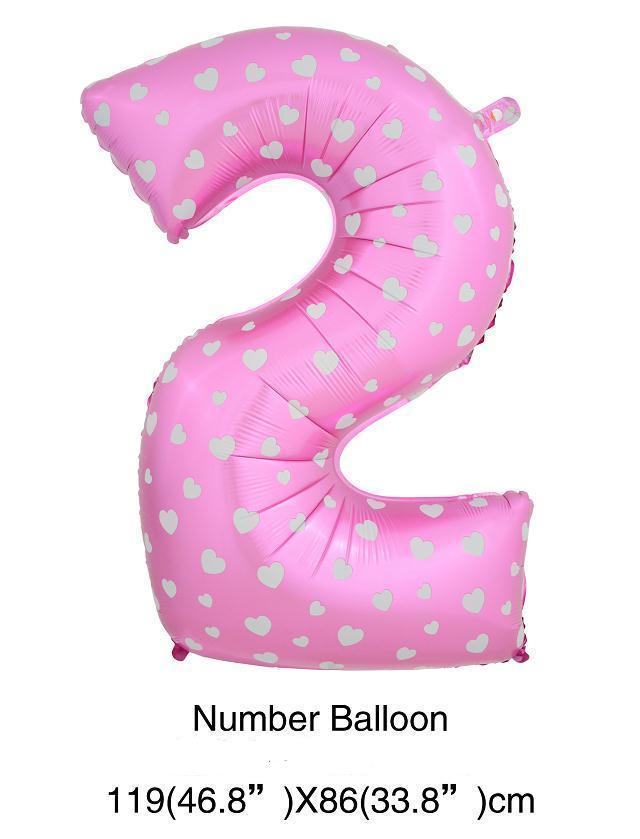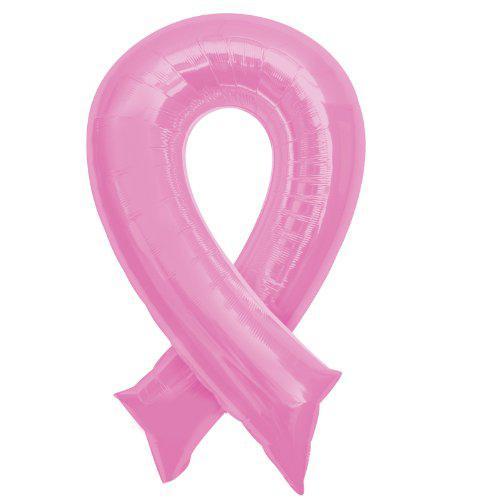The first image is the image on the left, the second image is the image on the right. For the images displayed, is the sentence "At least one balloon is shaped like a number." factually correct? Answer yes or no. Yes. The first image is the image on the left, the second image is the image on the right. For the images shown, is this caption "One image shows a balloon that is in the shape of a number" true? Answer yes or no. Yes. 